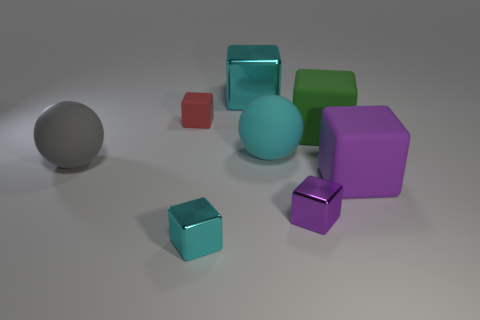There is a big purple thing that is the same shape as the small purple thing; what material is it?
Provide a short and direct response. Rubber. Is there any other thing that has the same size as the gray matte object?
Offer a terse response. Yes. There is a large cube right of the large green object; is its color the same as the matte ball on the right side of the tiny rubber cube?
Offer a terse response. No. What shape is the large green matte object?
Offer a very short reply. Cube. Is the number of red matte things that are behind the large cyan block greater than the number of large purple rubber objects?
Your response must be concise. No. What is the shape of the cyan object that is behind the tiny red thing?
Provide a succinct answer. Cube. What number of other things are the same shape as the small rubber object?
Your answer should be compact. 5. Are the small object left of the tiny cyan metallic cube and the small cyan object made of the same material?
Ensure brevity in your answer.  No. Are there an equal number of red things in front of the red matte cube and large cyan spheres that are to the left of the large gray ball?
Provide a succinct answer. Yes. There is a cyan metallic thing that is on the right side of the small cyan metal cube; how big is it?
Your answer should be very brief. Large. 